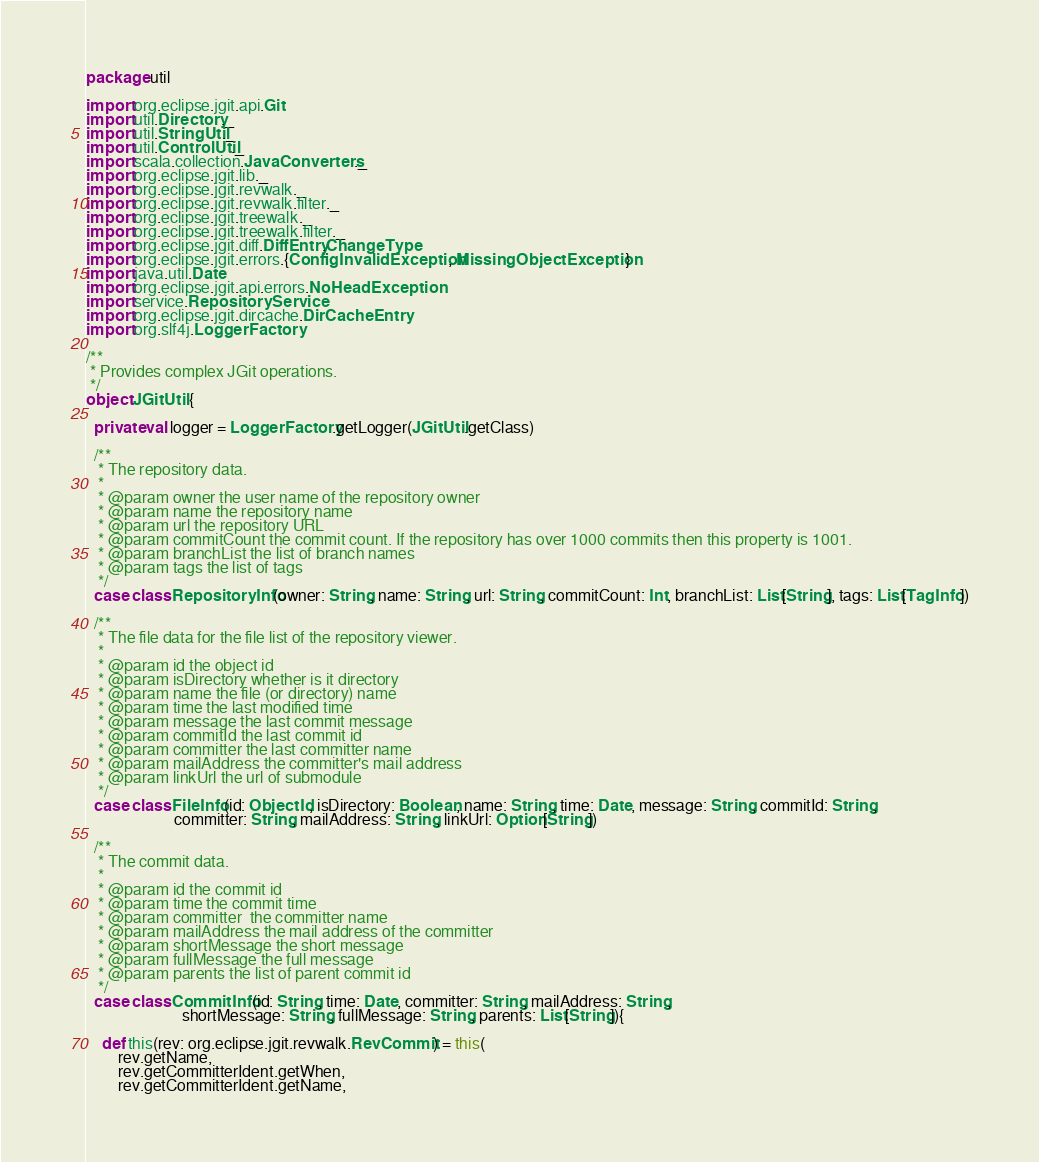Convert code to text. <code><loc_0><loc_0><loc_500><loc_500><_Scala_>package util

import org.eclipse.jgit.api.Git
import util.Directory._
import util.StringUtil._
import util.ControlUtil._
import scala.collection.JavaConverters._
import org.eclipse.jgit.lib._
import org.eclipse.jgit.revwalk._
import org.eclipse.jgit.revwalk.filter._
import org.eclipse.jgit.treewalk._
import org.eclipse.jgit.treewalk.filter._
import org.eclipse.jgit.diff.DiffEntry.ChangeType
import org.eclipse.jgit.errors.{ConfigInvalidException, MissingObjectException}
import java.util.Date
import org.eclipse.jgit.api.errors.NoHeadException
import service.RepositoryService
import org.eclipse.jgit.dircache.DirCacheEntry
import org.slf4j.LoggerFactory

/**
 * Provides complex JGit operations.
 */
object JGitUtil {

  private val logger = LoggerFactory.getLogger(JGitUtil.getClass)

  /**
   * The repository data.
   *
   * @param owner the user name of the repository owner
   * @param name the repository name
   * @param url the repository URL
   * @param commitCount the commit count. If the repository has over 1000 commits then this property is 1001.
   * @param branchList the list of branch names
   * @param tags the list of tags
   */
  case class RepositoryInfo(owner: String, name: String, url: String, commitCount: Int, branchList: List[String], tags: List[TagInfo])

  /**
   * The file data for the file list of the repository viewer.
   *
   * @param id the object id
   * @param isDirectory whether is it directory
   * @param name the file (or directory) name
   * @param time the last modified time
   * @param message the last commit message
   * @param commitId the last commit id
   * @param committer the last committer name
   * @param mailAddress the committer's mail address
   * @param linkUrl the url of submodule
   */
  case class FileInfo(id: ObjectId, isDirectory: Boolean, name: String, time: Date, message: String, commitId: String,
                      committer: String, mailAddress: String, linkUrl: Option[String])

  /**
   * The commit data.
   *
   * @param id the commit id
   * @param time the commit time
   * @param committer  the committer name
   * @param mailAddress the mail address of the committer
   * @param shortMessage the short message
   * @param fullMessage the full message
   * @param parents the list of parent commit id
   */
  case class CommitInfo(id: String, time: Date, committer: String, mailAddress: String,
                        shortMessage: String, fullMessage: String, parents: List[String]){
    
    def this(rev: org.eclipse.jgit.revwalk.RevCommit) = this(
        rev.getName,
        rev.getCommitterIdent.getWhen,
        rev.getCommitterIdent.getName,</code> 